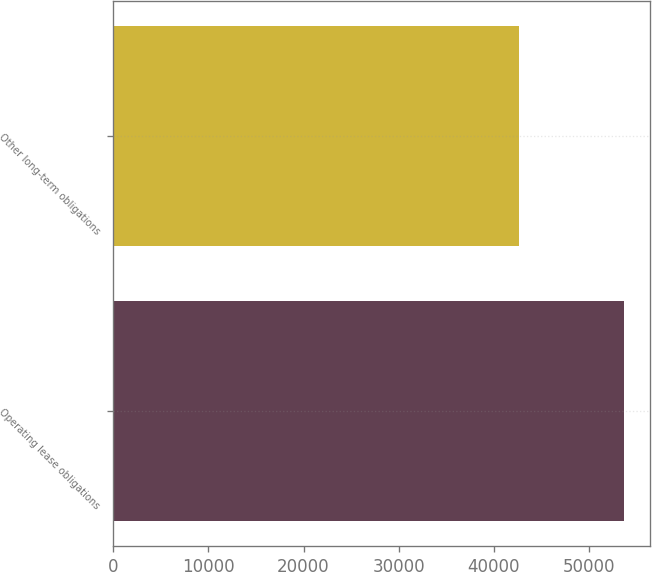Convert chart. <chart><loc_0><loc_0><loc_500><loc_500><bar_chart><fcel>Operating lease obligations<fcel>Other long-term obligations<nl><fcel>53712<fcel>42689<nl></chart> 